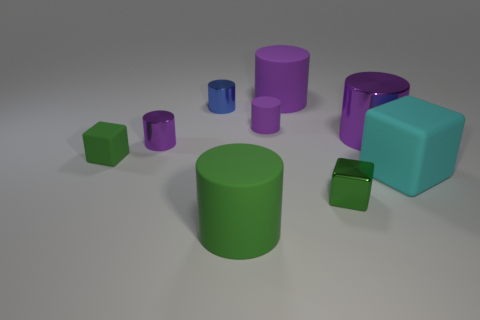Is the number of small metal things that are right of the green metal thing the same as the number of big purple cylinders?
Your response must be concise. No. Is the size of the green cube to the right of the green matte cylinder the same as the cyan rubber object?
Provide a short and direct response. No. What number of small shiny cubes are there?
Your answer should be compact. 1. How many cylinders are to the right of the blue object and behind the green cylinder?
Provide a short and direct response. 3. Are there any small cubes made of the same material as the big cyan thing?
Keep it short and to the point. Yes. There is a small purple cylinder in front of the big purple metallic thing that is in front of the tiny matte cylinder; what is its material?
Keep it short and to the point. Metal. Are there an equal number of green rubber objects that are right of the large green thing and tiny cylinders that are behind the large purple metal object?
Your answer should be compact. No. Do the small green matte thing and the tiny green metal thing have the same shape?
Your response must be concise. Yes. The big object that is both in front of the small purple metal object and behind the large green cylinder is made of what material?
Your answer should be compact. Rubber. What number of other objects have the same shape as the small green metal object?
Offer a very short reply. 2. 